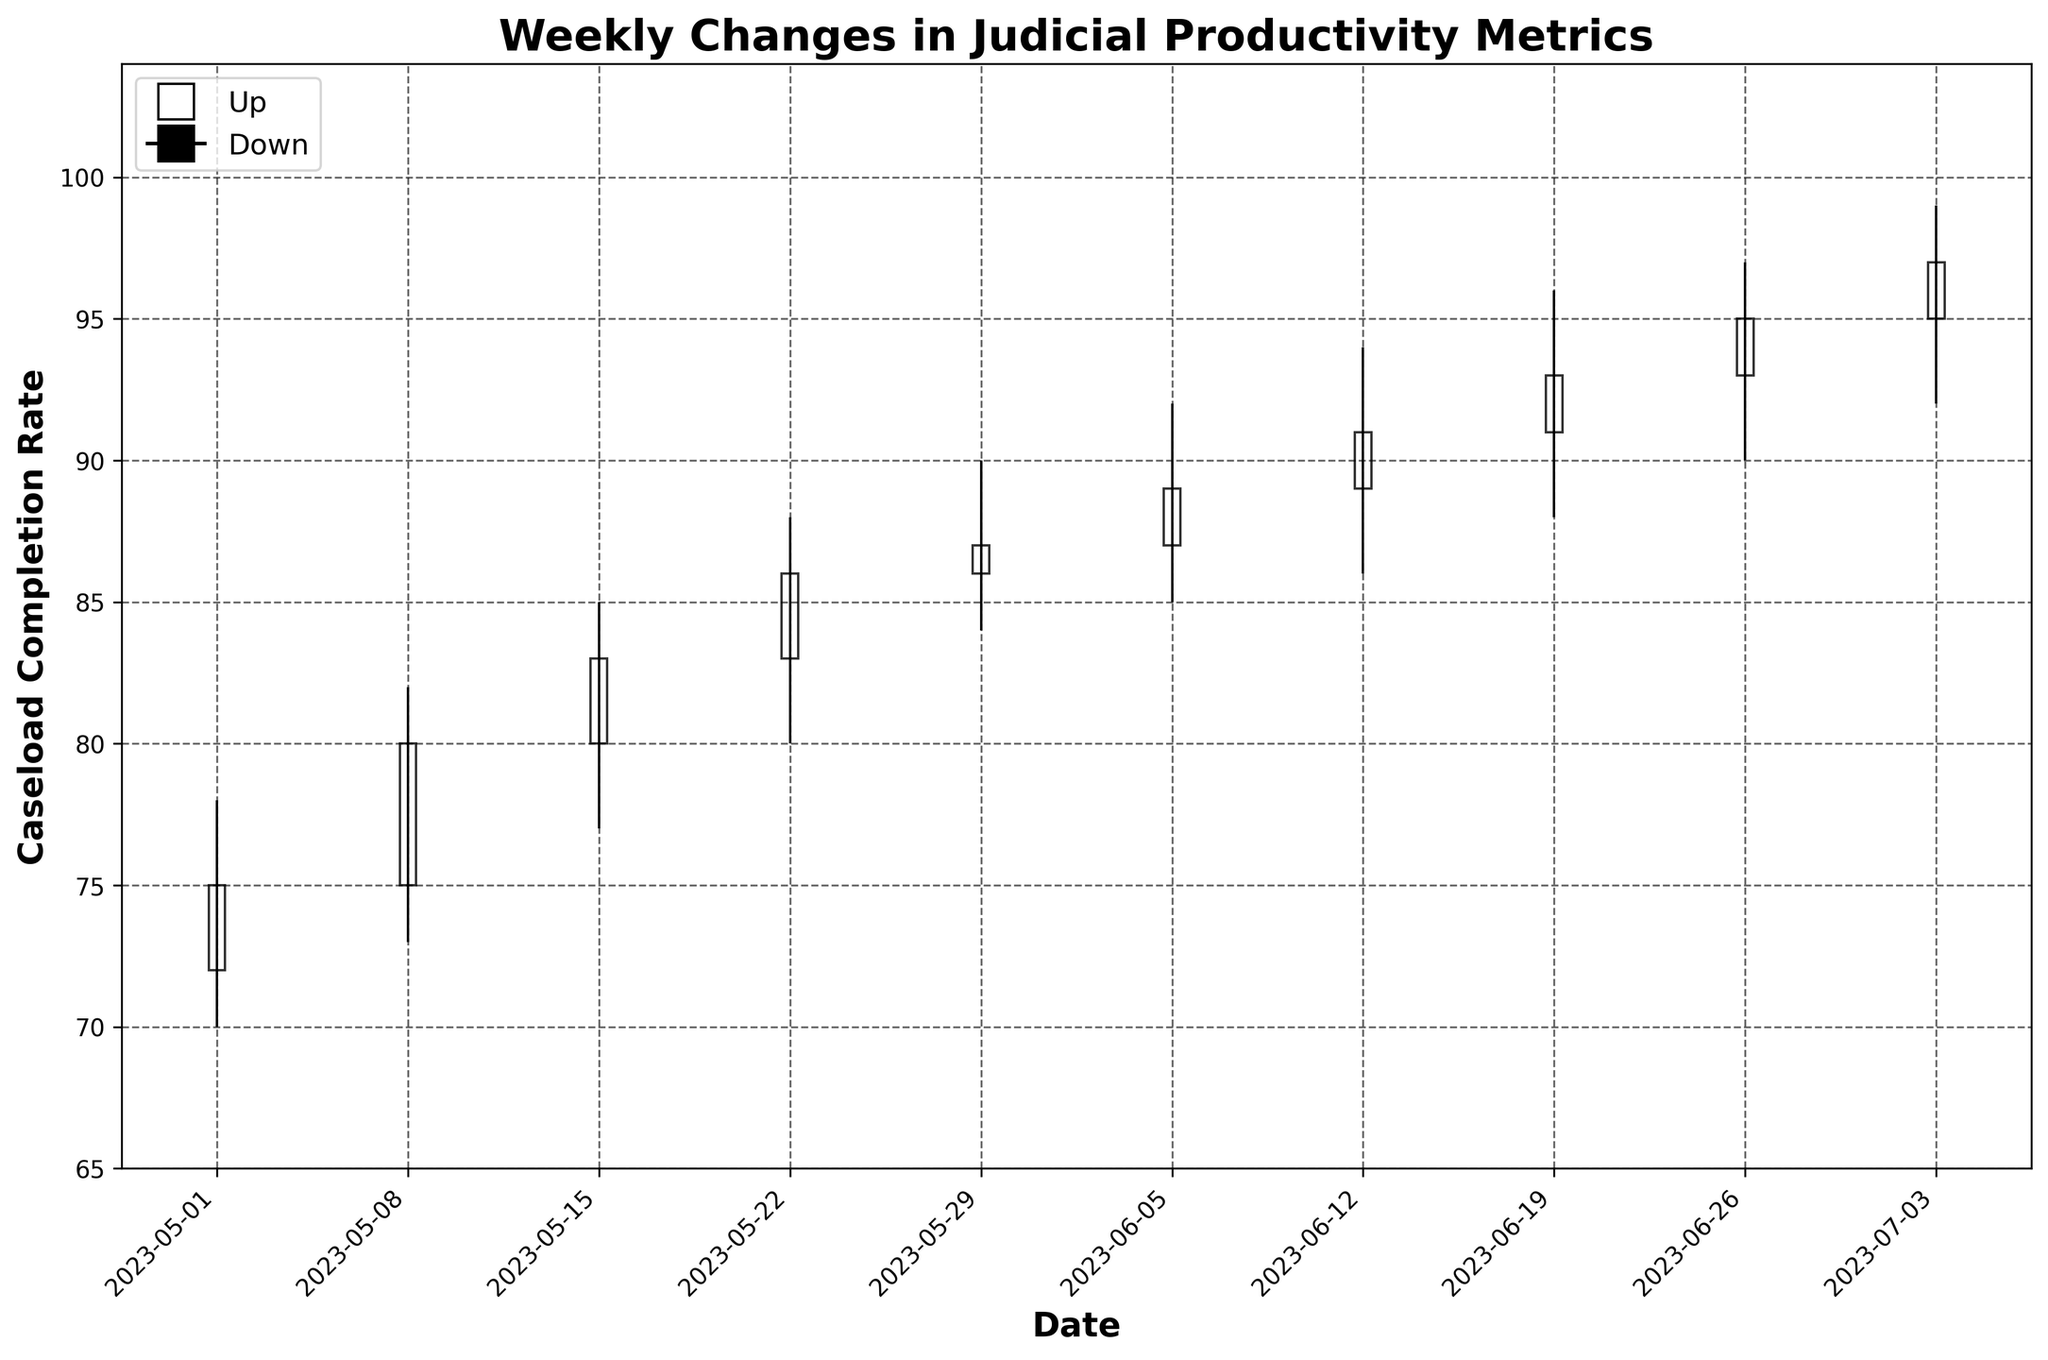What is the title of the figure? The title of the figure is displayed at the top center and indicates the subject or purpose of the plot. For this figure, it is showing the weekly changes in judicial productivity metrics.
Answer: Weekly Changes in Judicial Productivity Metrics What is the caseload completion rate on 2023-05-22? Find the date 2023-05-22 on the x-axis. The rate is marked by the closing value on that date, as shown by the top of the bar.
Answer: 86 What is the trend of the caseload completion rate from 2023-05-01 to 2023-07-03? Observe the closing values for each week from the first to the last date. If the closing points consistently increase, the trend is upward; if they decrease, the trend is downward. Here, the closing values increase each week.
Answer: Upward Which week experienced the highest caseload completion rate? Locate the week with the highest closing value on the y-axis. The week ending on 2023-07-03 has the highest closing value of 97.
Answer: 2023-07-03 How does the high-low range of 2023-06-05 compare to 2023-06-12? Compare the high and low values of both dates. For 2023-06-05, it ranges from 85 to 92; for 2023-06-12, it ranges from 86 to 94. The latter has a broader range.
Answer: 2023-06-12 has a broader range Which week shows the largest increase in the caseload completion rate from its opening to its closing value? Calculate the difference between the closing and opening values for each week and identify the week with the maximum difference. 2023-05-08 has a difference of 5 (80 - 75).
Answer: 2023-05-08 How many weeks have their closing values higher than the opening values? Count the number of weeks where the closing value is higher than the opening value. This is indicated by white bars in the plot.
Answer: 10 weeks On which date did the caseload completion rate have the smallest difference between its high and low values? Identify the smallest difference between the high and low values for all dates. The smallest difference is observed on 2023-05-29 (90 - 84 = 6).
Answer: 2023-05-29 What is the average of the closing values for the first three weeks shown? Add up the closing values of the first three weeks (75, 80, 83) and divide by 3 to find the average. Sum is 238, dividing by 3 gives approximately 79.33.
Answer: 79.33 